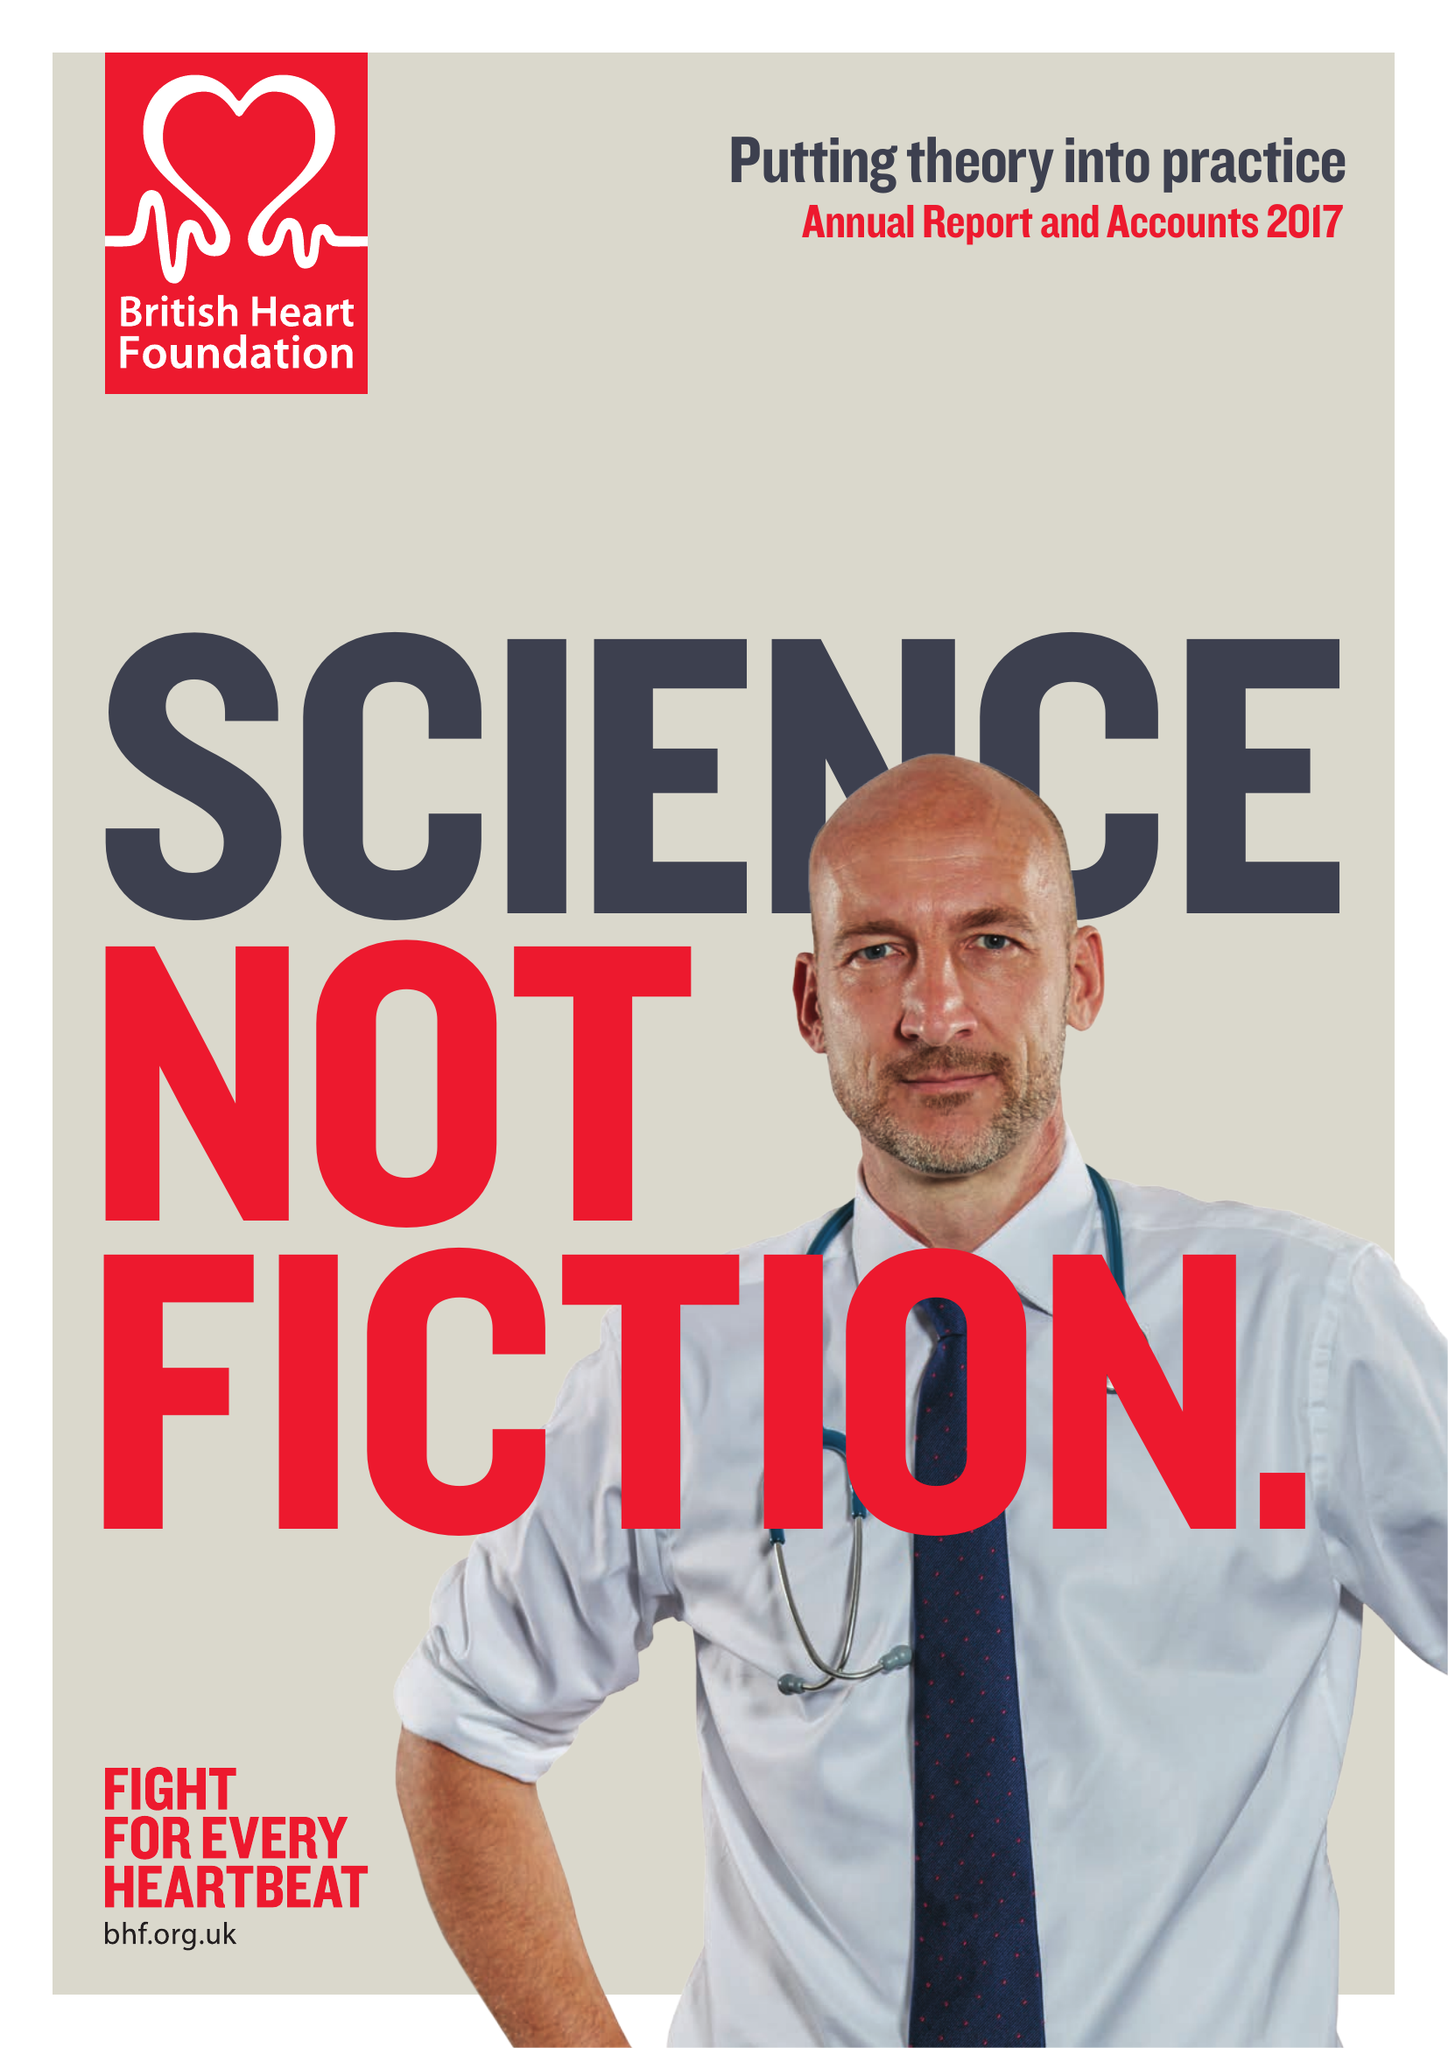What is the value for the charity_number?
Answer the question using a single word or phrase. 225971 